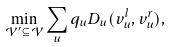Convert formula to latex. <formula><loc_0><loc_0><loc_500><loc_500>\min _ { \mathcal { V } ^ { \prime } \subseteq \mathcal { V } } \sum _ { u } q _ { u } D _ { u } ( v _ { u } ^ { l } , v _ { u } ^ { r } ) ,</formula> 